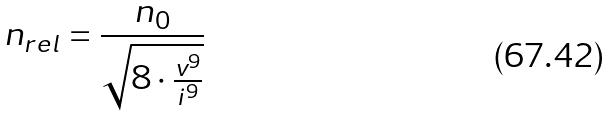<formula> <loc_0><loc_0><loc_500><loc_500>n _ { r e l } = \frac { n _ { 0 } } { \sqrt { 8 \cdot \frac { v ^ { 9 } } { i ^ { 9 } } } }</formula> 